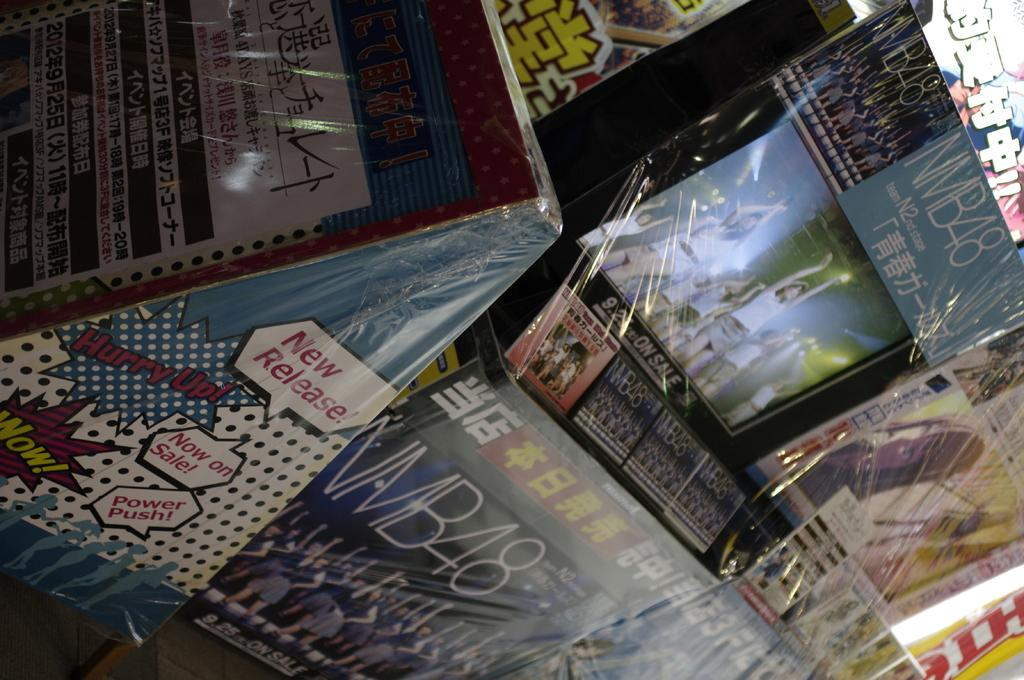<image>
Render a clear and concise summary of the photo. Store full of albums and new releases that are on sale now. 